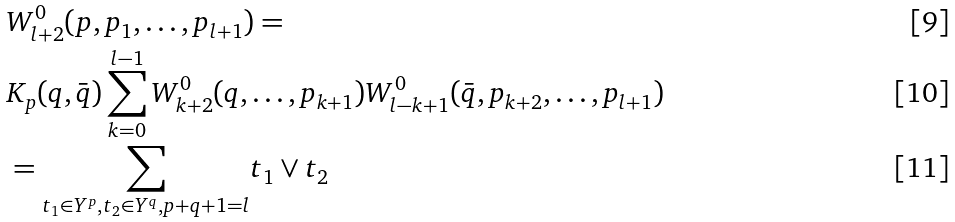<formula> <loc_0><loc_0><loc_500><loc_500>& W ^ { 0 } _ { l + 2 } ( p , p _ { 1 } , \dots , p _ { l + 1 } ) = \\ & K _ { p } ( q , \bar { q } ) \sum _ { k = 0 } ^ { l - 1 } W ^ { 0 } _ { k + 2 } ( q , \dots , p _ { k + 1 } ) W ^ { 0 } _ { l - k + 1 } ( \bar { q } , p _ { k + 2 } , \dots , p _ { l + 1 } ) \\ & = \underset { t _ { 1 } \in Y ^ { p } , t _ { 2 } \in Y ^ { q } , p + q + 1 = l } { \sum } t _ { 1 } \vee t _ { 2 }</formula> 